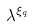Convert formula to latex. <formula><loc_0><loc_0><loc_500><loc_500>\lambda ^ { \xi _ { q } }</formula> 